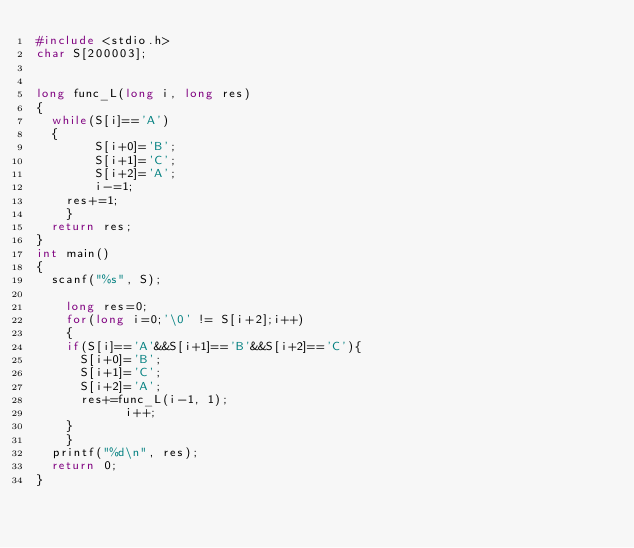Convert code to text. <code><loc_0><loc_0><loc_500><loc_500><_C_>#include <stdio.h>
char S[200003];


long func_L(long i, long res)
{
	while(S[i]=='A')
	{
        S[i+0]='B';
        S[i+1]='C';
        S[i+2]='A';
        i-=1;
		res+=1;
    }
	return res;
}
int main()
{
	scanf("%s", S);

    long res=0;
    for(long i=0;'\0' != S[i+2];i++)
    {
		if(S[i]=='A'&&S[i+1]=='B'&&S[i+2]=='C'){
			S[i+0]='B';
			S[i+1]='C';
			S[i+2]='A';
			res+=func_L(i-1, 1);
            i++;
		}
    }
	printf("%d\n", res);
	return 0;
}</code> 